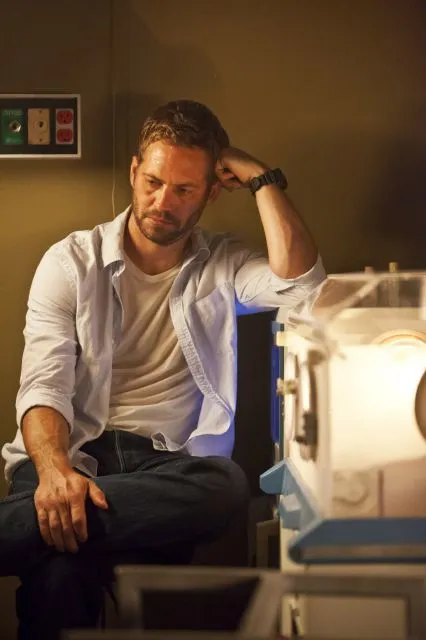Describe the scene in a very detailed manner. In the scene, we observe a man seated on a desk within a laboratory environment. His attire is casual yet professional, consisting of a white button-down shirt, a white t-shirt, and blue jeans. His left arm is bent, with his hand resting wearily on his head, while his right arm hangs down, with his hand placed on his knee. The man's facial expression is one of deep thought or concern, as he stares intently ahead. The laboratory is equipped with various scientific apparatuses, including a large, translucent machine on his right, possibly an incubator or a specialized piece of lab equipment. The lighting in the room is dim, casting shadows that emphasize the man's contemplative mood. On the wall behind him, there are electrical outlets, hinting at the use of electronic devices. The overall atmosphere suggests a moment of pause in the midst of intense scientific work. What could be some possible backgrounds or backstories for this scene? There are several intriguing possibilities for the backstory of this scene: 
1. **Scientific Breakthrough:** The man might be a scientist who has just made a significant discovery. The mixture of relief and pressure from the revelation could be weighing on his mind as he contemplates the implications of his work. 
2. **Personal Struggle:** He could be reflecting on a personal or ethical dilemma related to his research. This setting might represent a moment of inner conflict where he is caught between the pursuit of scientific advancement and moral considerations. 
3. **Last-Ditch Effort:** Perhaps the man is working on a critical project with a tight deadline. The contemplative pose might indicate the physical and mental exhaustion of putting in long hours in the lab, with the weight of a major breakthrough or failure hanging in the balance. 
4. **Mourning a Loss:** The setting could represent a moment of grief or loss, where the lab is a refuge, and his posture signifies someone processing complex emotions while surrounded by the familiar comforts of his work environment. Each of these backstories adds a layer of depth and context to the man’s contemplative pose, enriching the narrative derived from the image. Imagine an alternate universe where the man is a fictional character. What kind of extraordinary abilities or background could he have? In an alternate universe, the man could be a brilliant scientist with the ability to manipulate time. This skill allows him to pause, rewind, and fast-forward time within his laboratory, giving him the unique advantage of perfecting his experiments without the constraints of real-time. His time-manipulating abilities allow him to conduct hundreds of iterations of experiments within minutes, making groundbreaking discoveries rapidly. However, with such power comes great responsibility. The contemplative pose in the image could signify the burden of knowing that every manipulation of time might have unforeseen consequences on the future. He could be weighing the ethical considerations of his actions, pondering the intricate balance between progress and the natural order. The specialized equipment in his lab might be tools to harness and control his abilities, amplifying or focusing his power for precise scientific purposes. His intense focus might indicate a critical moment where he has to decide whether to use his abilities to alter a significant, world-changing event or to let time flow naturally. In this narrative, the science fiction elements blend with ethical dilemmas, creating a rich and compelling alternate universe for the character. 